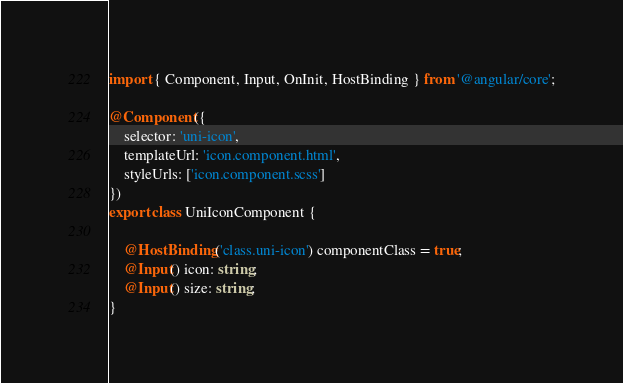<code> <loc_0><loc_0><loc_500><loc_500><_TypeScript_>import { Component, Input, OnInit, HostBinding } from '@angular/core';

@Component({
    selector: 'uni-icon',
    templateUrl: 'icon.component.html',
    styleUrls: ['icon.component.scss']
})
export class UniIconComponent {

    @HostBinding('class.uni-icon') componentClass = true;
    @Input() icon: string;
    @Input() size: string;
}
</code> 